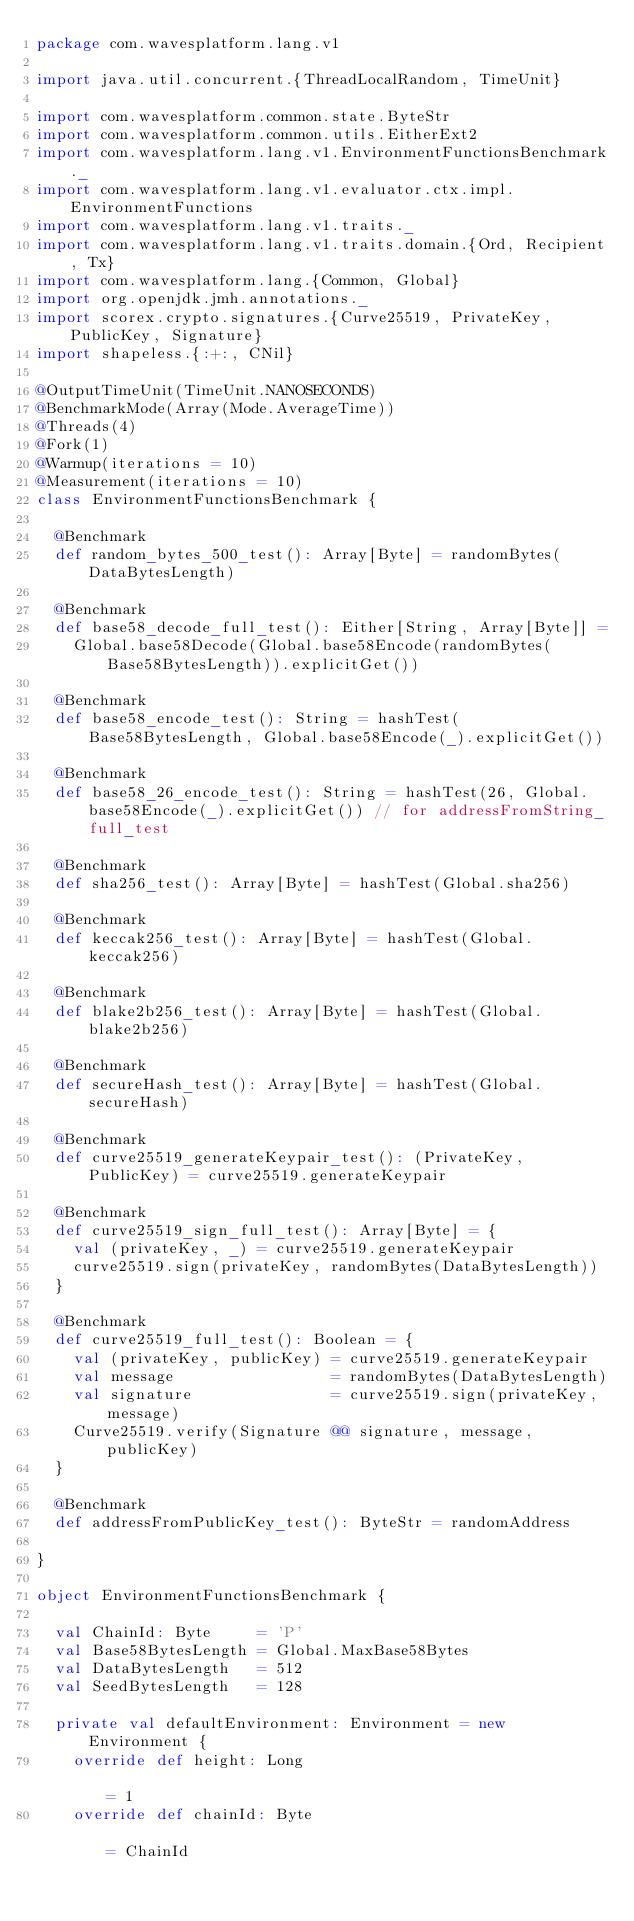<code> <loc_0><loc_0><loc_500><loc_500><_Scala_>package com.wavesplatform.lang.v1

import java.util.concurrent.{ThreadLocalRandom, TimeUnit}

import com.wavesplatform.common.state.ByteStr
import com.wavesplatform.common.utils.EitherExt2
import com.wavesplatform.lang.v1.EnvironmentFunctionsBenchmark._
import com.wavesplatform.lang.v1.evaluator.ctx.impl.EnvironmentFunctions
import com.wavesplatform.lang.v1.traits._
import com.wavesplatform.lang.v1.traits.domain.{Ord, Recipient, Tx}
import com.wavesplatform.lang.{Common, Global}
import org.openjdk.jmh.annotations._
import scorex.crypto.signatures.{Curve25519, PrivateKey, PublicKey, Signature}
import shapeless.{:+:, CNil}

@OutputTimeUnit(TimeUnit.NANOSECONDS)
@BenchmarkMode(Array(Mode.AverageTime))
@Threads(4)
@Fork(1)
@Warmup(iterations = 10)
@Measurement(iterations = 10)
class EnvironmentFunctionsBenchmark {

  @Benchmark
  def random_bytes_500_test(): Array[Byte] = randomBytes(DataBytesLength)

  @Benchmark
  def base58_decode_full_test(): Either[String, Array[Byte]] =
    Global.base58Decode(Global.base58Encode(randomBytes(Base58BytesLength)).explicitGet())

  @Benchmark
  def base58_encode_test(): String = hashTest(Base58BytesLength, Global.base58Encode(_).explicitGet())

  @Benchmark
  def base58_26_encode_test(): String = hashTest(26, Global.base58Encode(_).explicitGet()) // for addressFromString_full_test

  @Benchmark
  def sha256_test(): Array[Byte] = hashTest(Global.sha256)

  @Benchmark
  def keccak256_test(): Array[Byte] = hashTest(Global.keccak256)

  @Benchmark
  def blake2b256_test(): Array[Byte] = hashTest(Global.blake2b256)

  @Benchmark
  def secureHash_test(): Array[Byte] = hashTest(Global.secureHash)

  @Benchmark
  def curve25519_generateKeypair_test(): (PrivateKey, PublicKey) = curve25519.generateKeypair

  @Benchmark
  def curve25519_sign_full_test(): Array[Byte] = {
    val (privateKey, _) = curve25519.generateKeypair
    curve25519.sign(privateKey, randomBytes(DataBytesLength))
  }

  @Benchmark
  def curve25519_full_test(): Boolean = {
    val (privateKey, publicKey) = curve25519.generateKeypair
    val message                 = randomBytes(DataBytesLength)
    val signature               = curve25519.sign(privateKey, message)
    Curve25519.verify(Signature @@ signature, message, publicKey)
  }

  @Benchmark
  def addressFromPublicKey_test(): ByteStr = randomAddress

}

object EnvironmentFunctionsBenchmark {

  val ChainId: Byte     = 'P'
  val Base58BytesLength = Global.MaxBase58Bytes
  val DataBytesLength   = 512
  val SeedBytesLength   = 128

  private val defaultEnvironment: Environment = new Environment {
    override def height: Long                                                                                    = 1
    override def chainId: Byte                                                                                   = ChainId</code> 